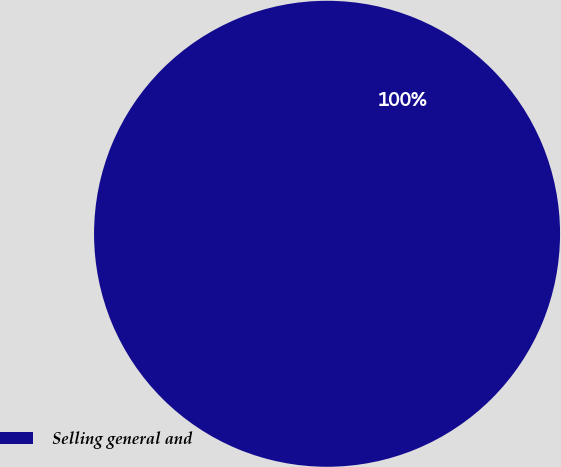Convert chart. <chart><loc_0><loc_0><loc_500><loc_500><pie_chart><fcel>Selling general and<nl><fcel>100.0%<nl></chart> 